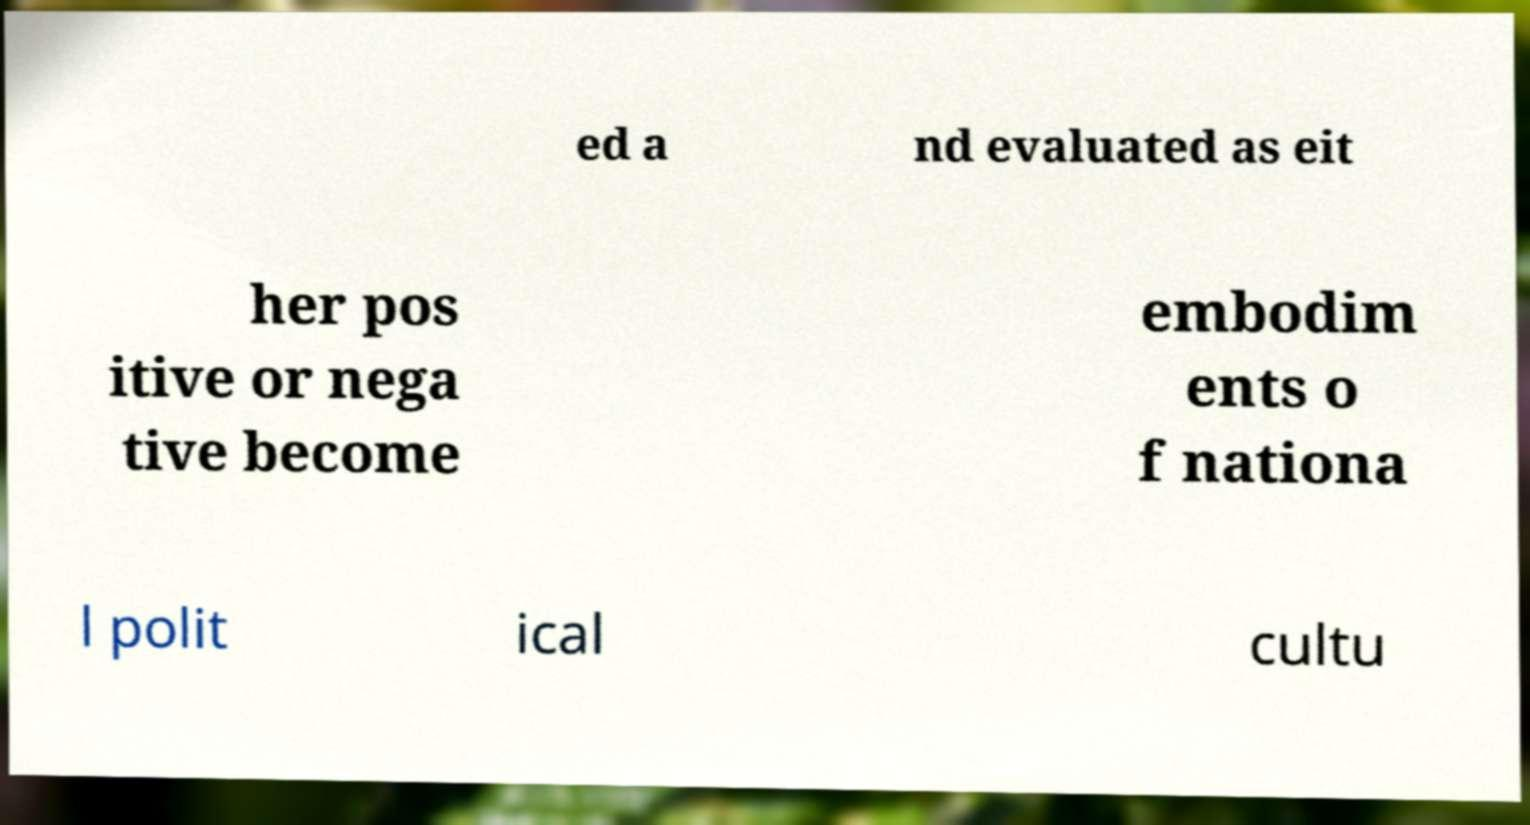Could you extract and type out the text from this image? ed a nd evaluated as eit her pos itive or nega tive become embodim ents o f nationa l polit ical cultu 